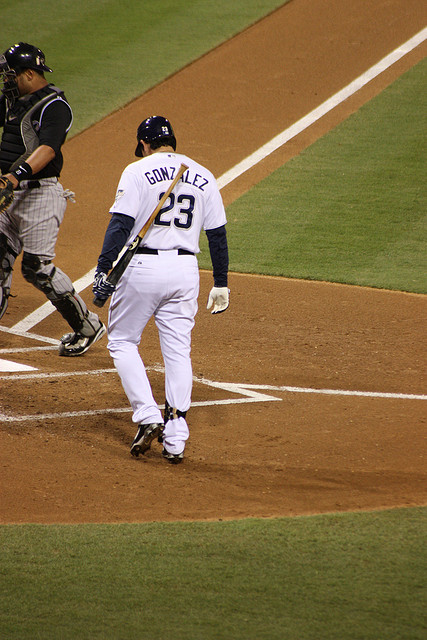Please identify all text content in this image. GONZALEZ 23 